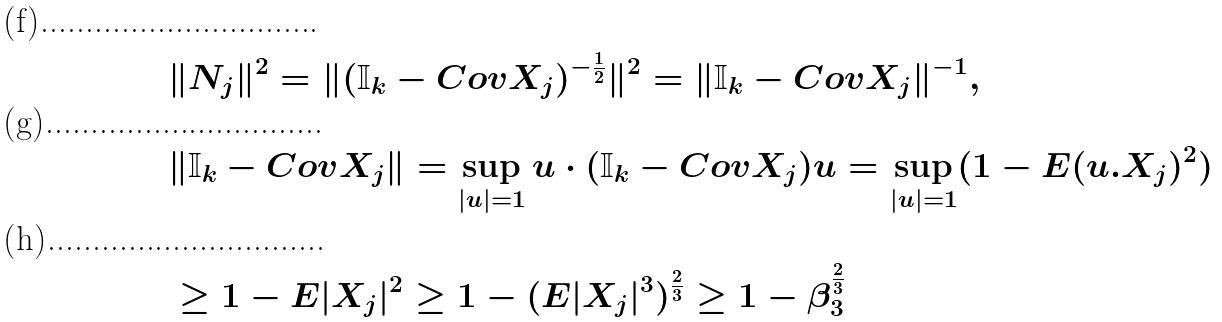Convert formula to latex. <formula><loc_0><loc_0><loc_500><loc_500>& \| N _ { j } \| ^ { 2 } = \| ( { \mathbb { I } _ { k } - C o v X _ { j } } ) ^ { - \frac { 1 } { 2 } } \| ^ { 2 } = \| { \mathbb { I } } _ { k } - C o v X _ { j } \| ^ { - 1 } , \\ & \| { \mathbb { I } } _ { k } - C o v X _ { j } \| = \sup _ { | u | = 1 } u \cdot ( { \mathbb { I } } _ { k } - C o v X _ { j } ) u = \sup _ { | u | = 1 } ( 1 - E ( u . X _ { j } ) ^ { 2 } ) \\ & \geq 1 - E | X _ { j } | ^ { 2 } \geq 1 - ( E | X _ { j } | ^ { 3 } ) ^ { \frac { 2 } { 3 } } \geq 1 - \beta _ { 3 } ^ { \frac { 2 } { 3 } }</formula> 